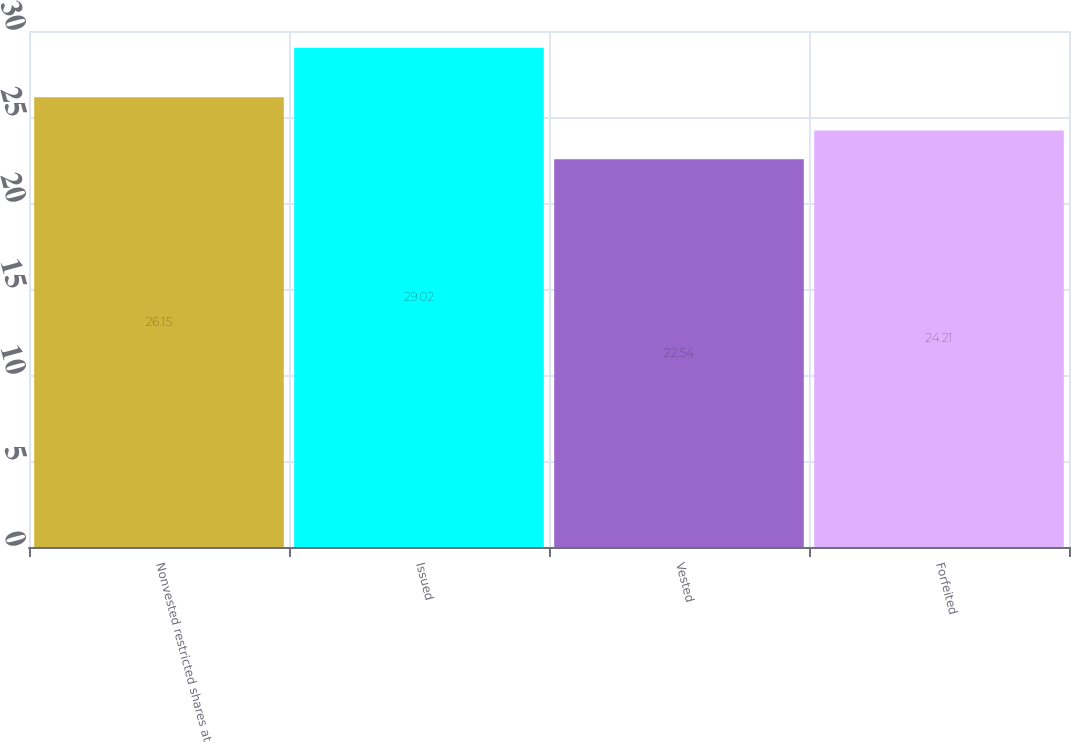Convert chart to OTSL. <chart><loc_0><loc_0><loc_500><loc_500><bar_chart><fcel>Nonvested restricted shares at<fcel>Issued<fcel>Vested<fcel>Forfeited<nl><fcel>26.15<fcel>29.02<fcel>22.54<fcel>24.21<nl></chart> 